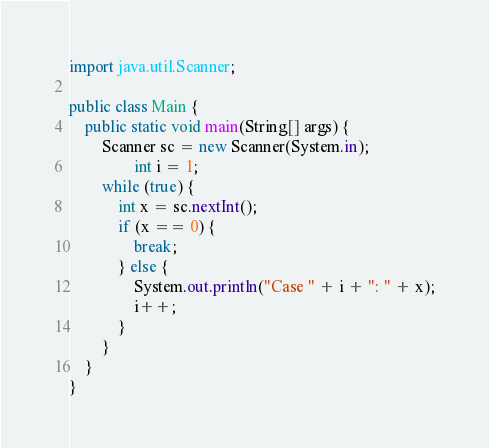Convert code to text. <code><loc_0><loc_0><loc_500><loc_500><_Java_>import java.util.Scanner;

public class Main {
	public static void main(String[] args) {
		Scanner sc = new Scanner(System.in);
				int i = 1;
		while (true) {
			int x = sc.nextInt();
			if (x == 0) {
				break;
			} else {
				System.out.println("Case " + i + ": " + x);
				i++;
			}
		}
	}
}
</code> 